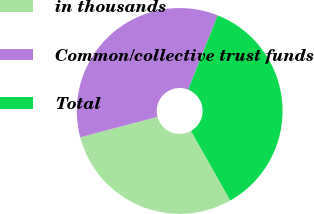<chart> <loc_0><loc_0><loc_500><loc_500><pie_chart><fcel>in thousands<fcel>Common/collective trust funds<fcel>Total<nl><fcel>29.07%<fcel>35.16%<fcel>35.77%<nl></chart> 